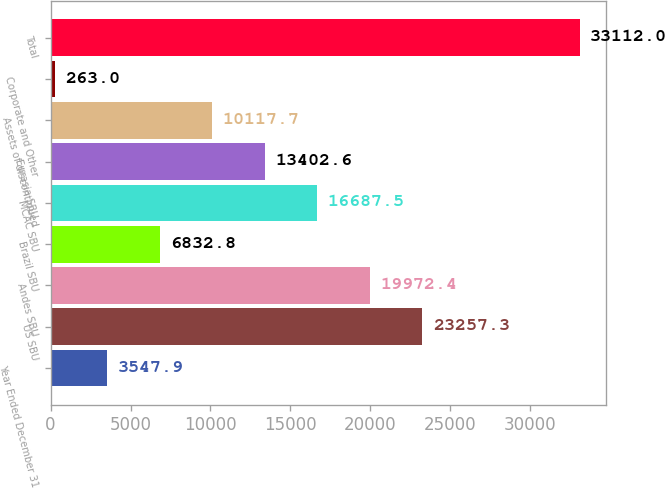Convert chart. <chart><loc_0><loc_0><loc_500><loc_500><bar_chart><fcel>Year Ended December 31<fcel>US SBU<fcel>Andes SBU<fcel>Brazil SBU<fcel>MCAC SBU<fcel>Eurasia SBU<fcel>Assets of discontinued<fcel>Corporate and Other<fcel>Total<nl><fcel>3547.9<fcel>23257.3<fcel>19972.4<fcel>6832.8<fcel>16687.5<fcel>13402.6<fcel>10117.7<fcel>263<fcel>33112<nl></chart> 